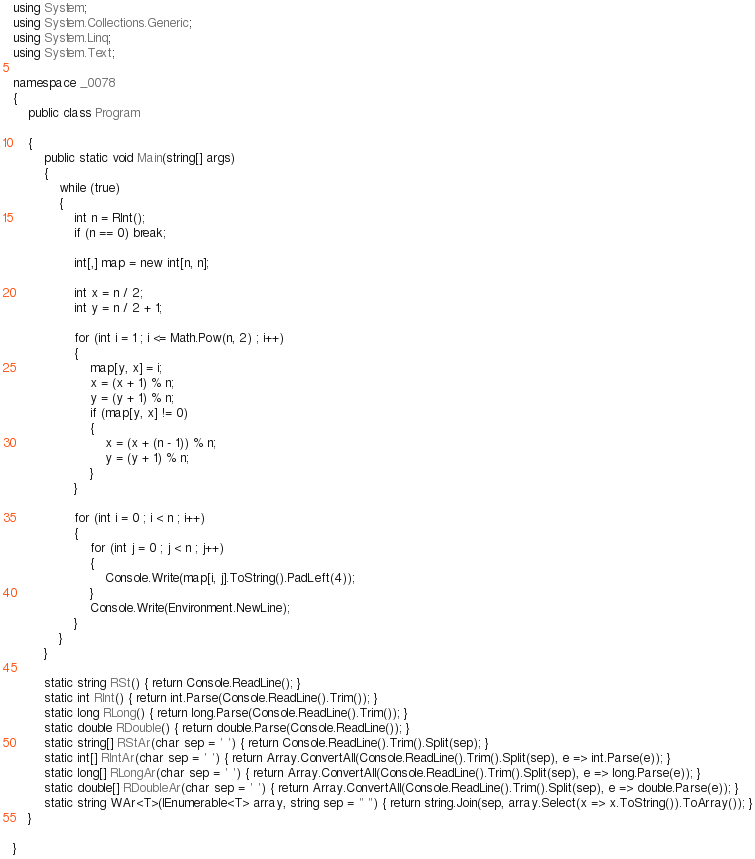<code> <loc_0><loc_0><loc_500><loc_500><_C#_>using System;
using System.Collections.Generic;
using System.Linq;
using System.Text;

namespace _0078
{
    public class Program

    {
        public static void Main(string[] args)
        {
            while (true)
            {
                int n = RInt();
                if (n == 0) break;

                int[,] map = new int[n, n];

                int x = n / 2;
                int y = n / 2 + 1;

                for (int i = 1 ; i <= Math.Pow(n, 2) ; i++)
                {
                    map[y, x] = i;
                    x = (x + 1) % n;
                    y = (y + 1) % n;
                    if (map[y, x] != 0)
                    {
                        x = (x + (n - 1)) % n;
                        y = (y + 1) % n;
                    }
                }

                for (int i = 0 ; i < n ; i++)
                {
                    for (int j = 0 ; j < n ; j++)
                    {
                        Console.Write(map[i, j].ToString().PadLeft(4));
                    }
                    Console.Write(Environment.NewLine);
                }
            }
        }

        static string RSt() { return Console.ReadLine(); }
        static int RInt() { return int.Parse(Console.ReadLine().Trim()); }
        static long RLong() { return long.Parse(Console.ReadLine().Trim()); }
        static double RDouble() { return double.Parse(Console.ReadLine()); }
        static string[] RStAr(char sep = ' ') { return Console.ReadLine().Trim().Split(sep); }
        static int[] RIntAr(char sep = ' ') { return Array.ConvertAll(Console.ReadLine().Trim().Split(sep), e => int.Parse(e)); }
        static long[] RLongAr(char sep = ' ') { return Array.ConvertAll(Console.ReadLine().Trim().Split(sep), e => long.Parse(e)); }
        static double[] RDoubleAr(char sep = ' ') { return Array.ConvertAll(Console.ReadLine().Trim().Split(sep), e => double.Parse(e)); }
        static string WAr<T>(IEnumerable<T> array, string sep = " ") { return string.Join(sep, array.Select(x => x.ToString()).ToArray()); }
    }

}

</code> 